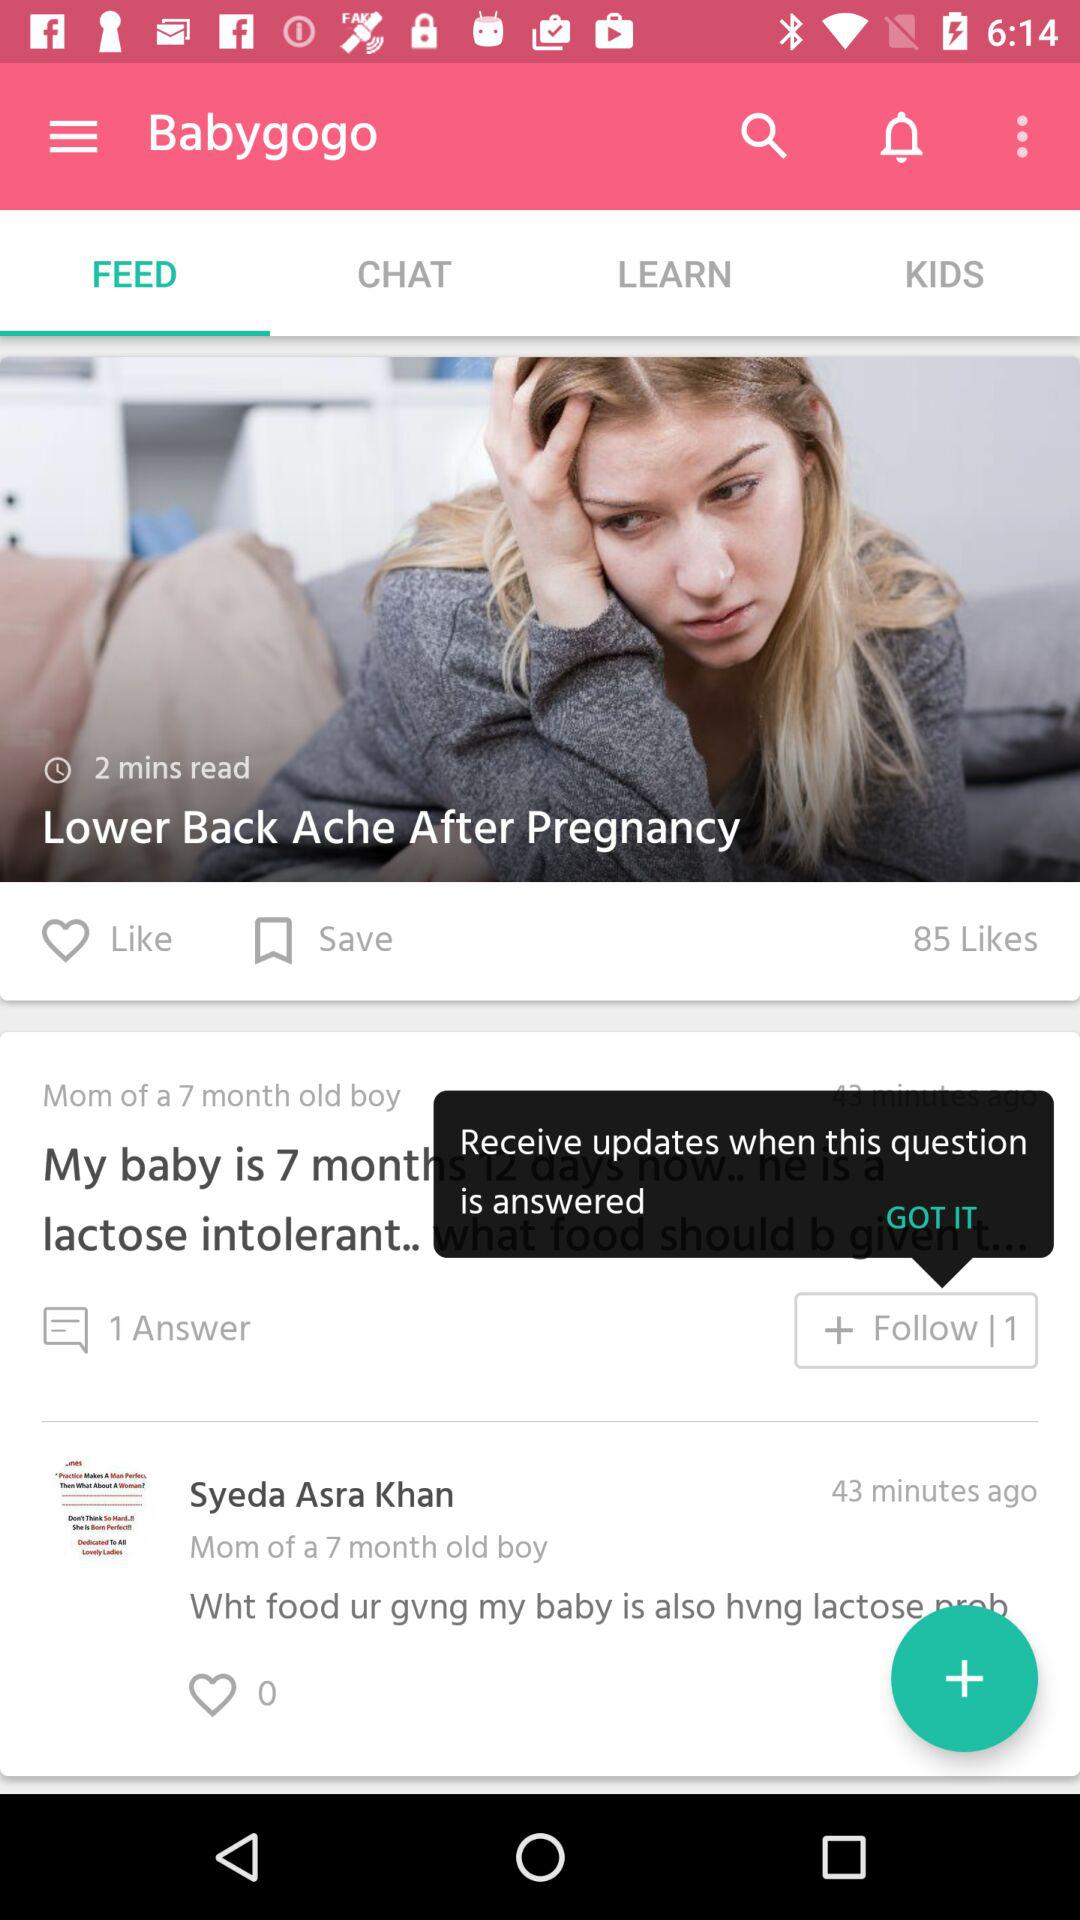How many responses were there to the question? There was one response to the question. 